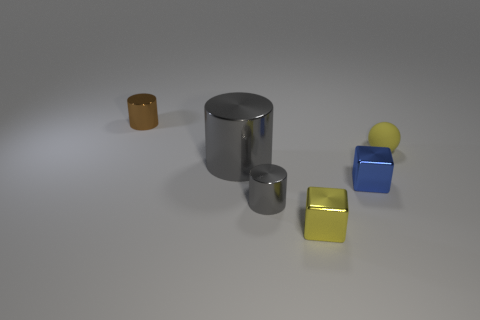Add 4 tiny spheres. How many objects exist? 10 Subtract all balls. How many objects are left? 5 Add 6 yellow rubber balls. How many yellow rubber balls are left? 7 Add 4 small gray metal cylinders. How many small gray metal cylinders exist? 5 Subtract 0 red cylinders. How many objects are left? 6 Subtract all tiny yellow blocks. Subtract all blue things. How many objects are left? 4 